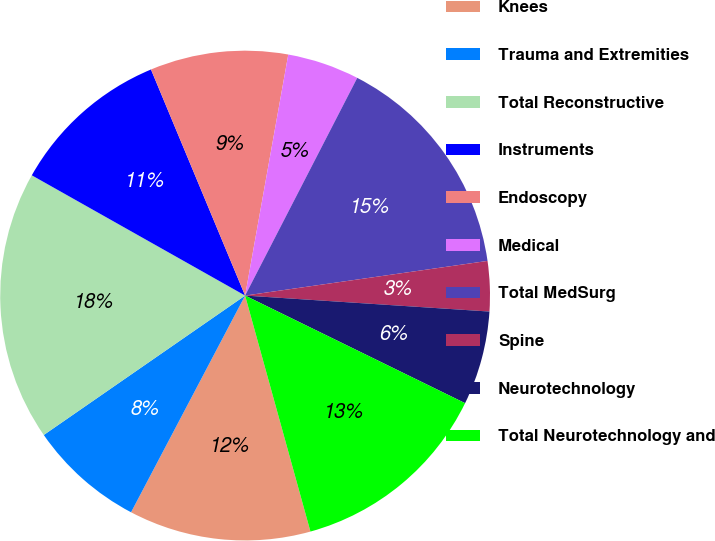<chart> <loc_0><loc_0><loc_500><loc_500><pie_chart><fcel>Knees<fcel>Trauma and Extremities<fcel>Total Reconstructive<fcel>Instruments<fcel>Endoscopy<fcel>Medical<fcel>Total MedSurg<fcel>Spine<fcel>Neurotechnology<fcel>Total Neurotechnology and<nl><fcel>12.01%<fcel>7.65%<fcel>17.81%<fcel>10.55%<fcel>9.1%<fcel>4.75%<fcel>15.17%<fcel>3.3%<fcel>6.2%<fcel>13.46%<nl></chart> 